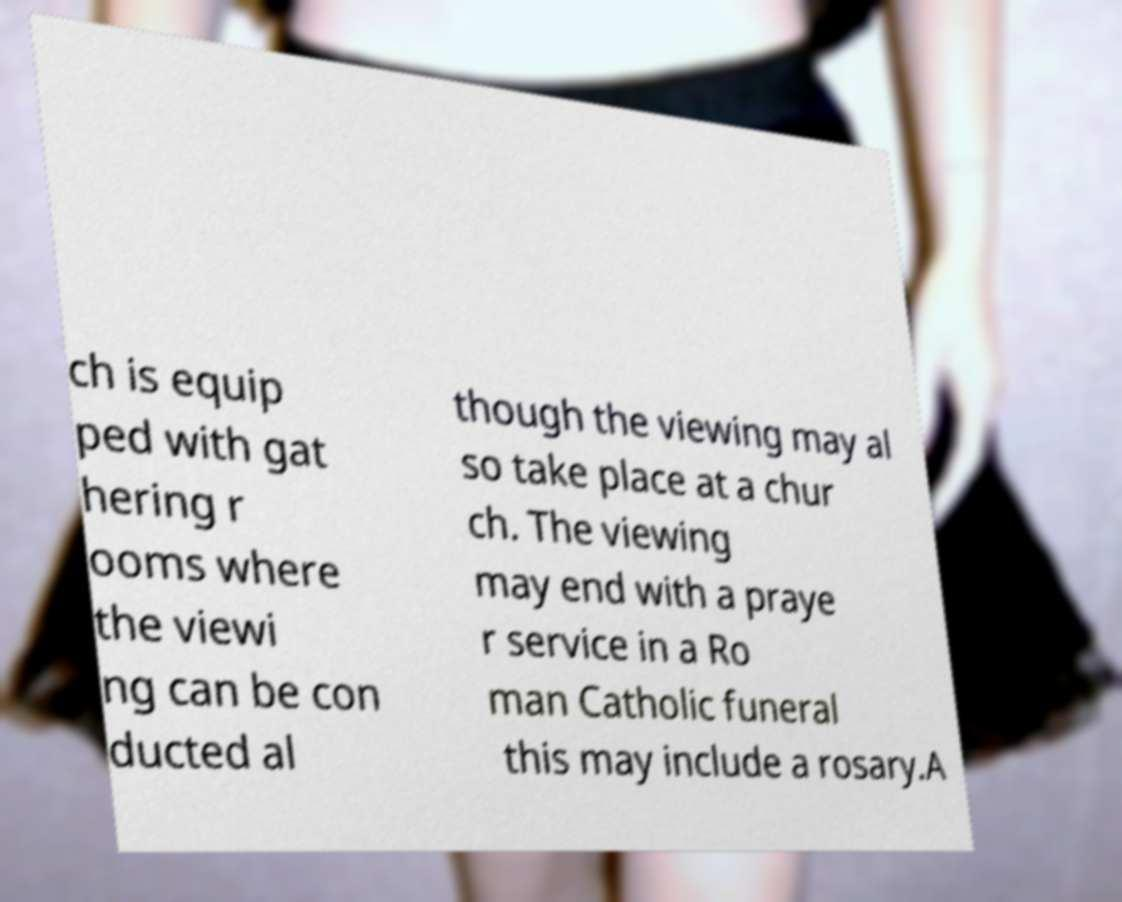Could you extract and type out the text from this image? ch is equip ped with gat hering r ooms where the viewi ng can be con ducted al though the viewing may al so take place at a chur ch. The viewing may end with a praye r service in a Ro man Catholic funeral this may include a rosary.A 